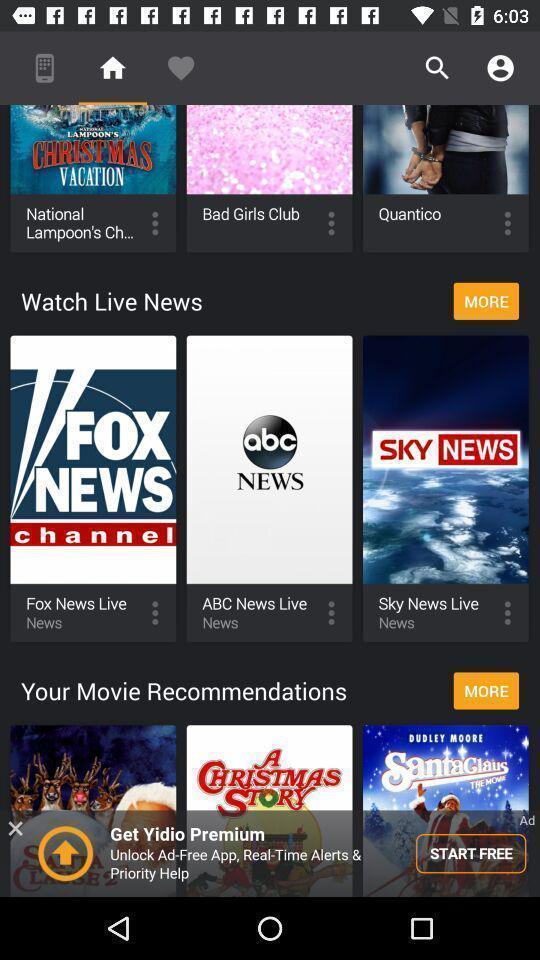Describe the content in this image. Various types of news channels in the application. 